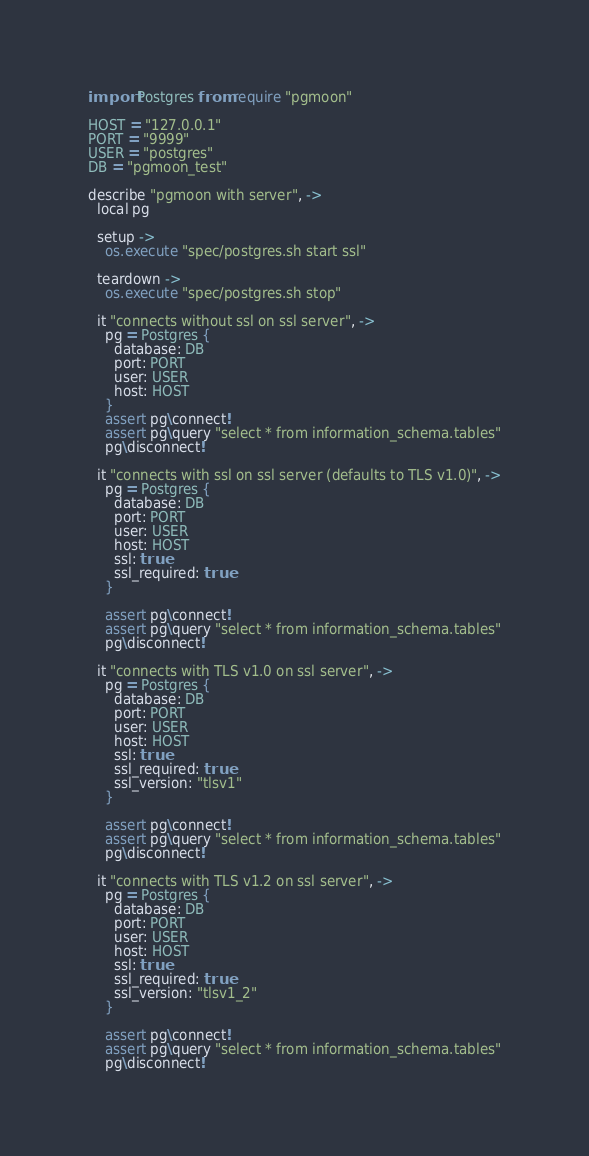Convert code to text. <code><loc_0><loc_0><loc_500><loc_500><_MoonScript_>import Postgres from require "pgmoon"

HOST = "127.0.0.1"
PORT = "9999"
USER = "postgres"
DB = "pgmoon_test"

describe "pgmoon with server", ->
  local pg

  setup ->
    os.execute "spec/postgres.sh start ssl"

  teardown ->
    os.execute "spec/postgres.sh stop"

  it "connects without ssl on ssl server", ->
    pg = Postgres {
      database: DB
      port: PORT
      user: USER
      host: HOST
    }
    assert pg\connect!
    assert pg\query "select * from information_schema.tables"
    pg\disconnect!

  it "connects with ssl on ssl server (defaults to TLS v1.0)", ->
    pg = Postgres {
      database: DB
      port: PORT
      user: USER
      host: HOST
      ssl: true
      ssl_required: true
    }

    assert pg\connect!
    assert pg\query "select * from information_schema.tables"
    pg\disconnect!

  it "connects with TLS v1.0 on ssl server", ->
    pg = Postgres {
      database: DB
      port: PORT
      user: USER
      host: HOST
      ssl: true
      ssl_required: true
      ssl_version: "tlsv1"
    }

    assert pg\connect!
    assert pg\query "select * from information_schema.tables"
    pg\disconnect!

  it "connects with TLS v1.2 on ssl server", ->
    pg = Postgres {
      database: DB
      port: PORT
      user: USER
      host: HOST
      ssl: true
      ssl_required: true
      ssl_version: "tlsv1_2"
    }

    assert pg\connect!
    assert pg\query "select * from information_schema.tables"
    pg\disconnect!


</code> 